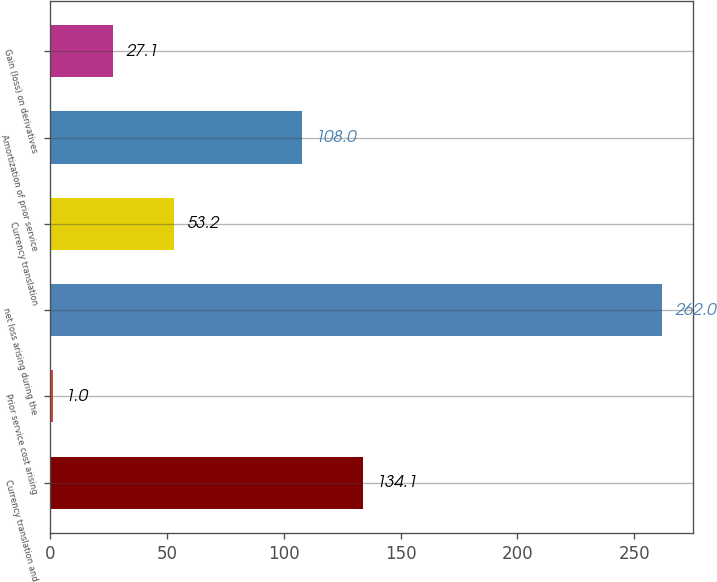Convert chart. <chart><loc_0><loc_0><loc_500><loc_500><bar_chart><fcel>Currency translation and<fcel>Prior service cost arising<fcel>net loss arising during the<fcel>Currency translation<fcel>Amortization of prior service<fcel>Gain (loss) on derivatives<nl><fcel>134.1<fcel>1<fcel>262<fcel>53.2<fcel>108<fcel>27.1<nl></chart> 